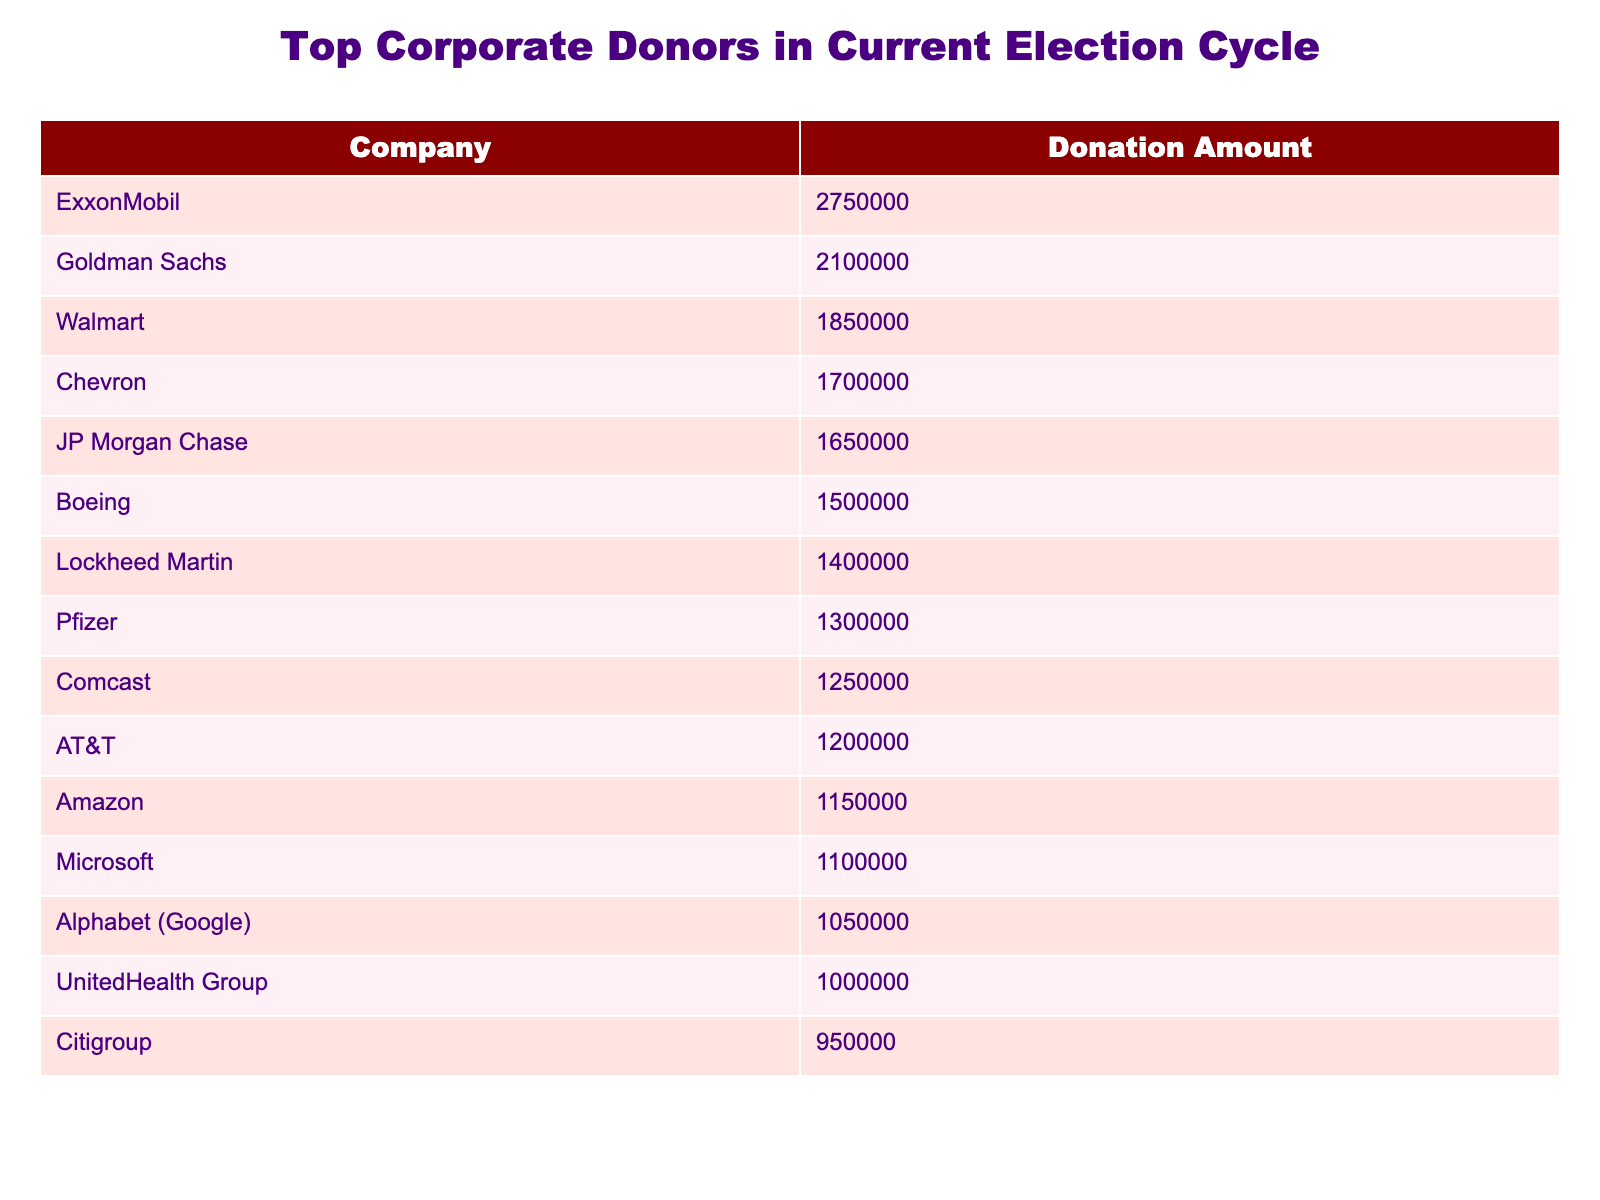What is the highest donation amount recorded in the table? The table shows that the highest donation amount belongs to ExxonMobil, which donated $2,750,000.
Answer: $2,750,000 Which company is the second-largest donor? By looking at the table, the second-largest donor is Goldman Sachs with a donation of $2,100,000.
Answer: Goldman Sachs How many companies donated more than $1,500,000? The table lists seven companies with donations that exceed $1,500,000: ExxonMobil, Goldman Sachs, Walmart, Chevron, JP Morgan Chase, Boeing, and Lockheed Martin.
Answer: 7 What is the total amount donated by the top three corporate donors? Summing the donations of the top three donors: $2,750,000 (ExxonMobil) + $2,100,000 (Goldman Sachs) + $1,850,000 (Walmart) results in a total of $6,700,000.
Answer: $6,700,000 Is Amazon among the top ten corporate donors? Yes, according to the table, Amazon is in the top ten donors, having donated $1,150,000.
Answer: Yes Which company donated the least amount among the top ten? Looking at the amounts, Citigroup donated the least among the top ten donors with $950,000.
Answer: Citigroup What is the average donation amount of the top ten corporate donors? To find the average, sum all the donations: ($2,750,000 + $2,100,000 + $1,850,000 + $1,700,000 + $1,650,000 + $1,500,000 + $1,400,000 + $1,300,000 + $1,250,000 + $1,200,000) = $15,450,000, and then divide by 10 (the number of donors): $15,450,000 / 10 = $1,545,000.
Answer: $1,545,000 Which company has a donation amount greater than $1,200,000 but less than $1,500,000? By checking the table, the only company that fits this criterion is Lockheed Martin, with a donation of $1,400,000.
Answer: Lockheed Martin How much more did ExxonMobil donate compared to Pfizer? The difference in their donations is calculated by subtracting Pfizer's donation of $1,300,000 from ExxonMobil's donation of $2,750,000, resulting in $1,450,000.
Answer: $1,450,000 Are there more companies who donated over $1,000,000 or under $1,000,000? Referring to the table, there are 12 companies that donated over $1,000,000 (the top ten plus two others) and 3 companies who donated less than $1,000,000, confirming that there are more companies above $1,000,000.
Answer: More above $1,000,000 